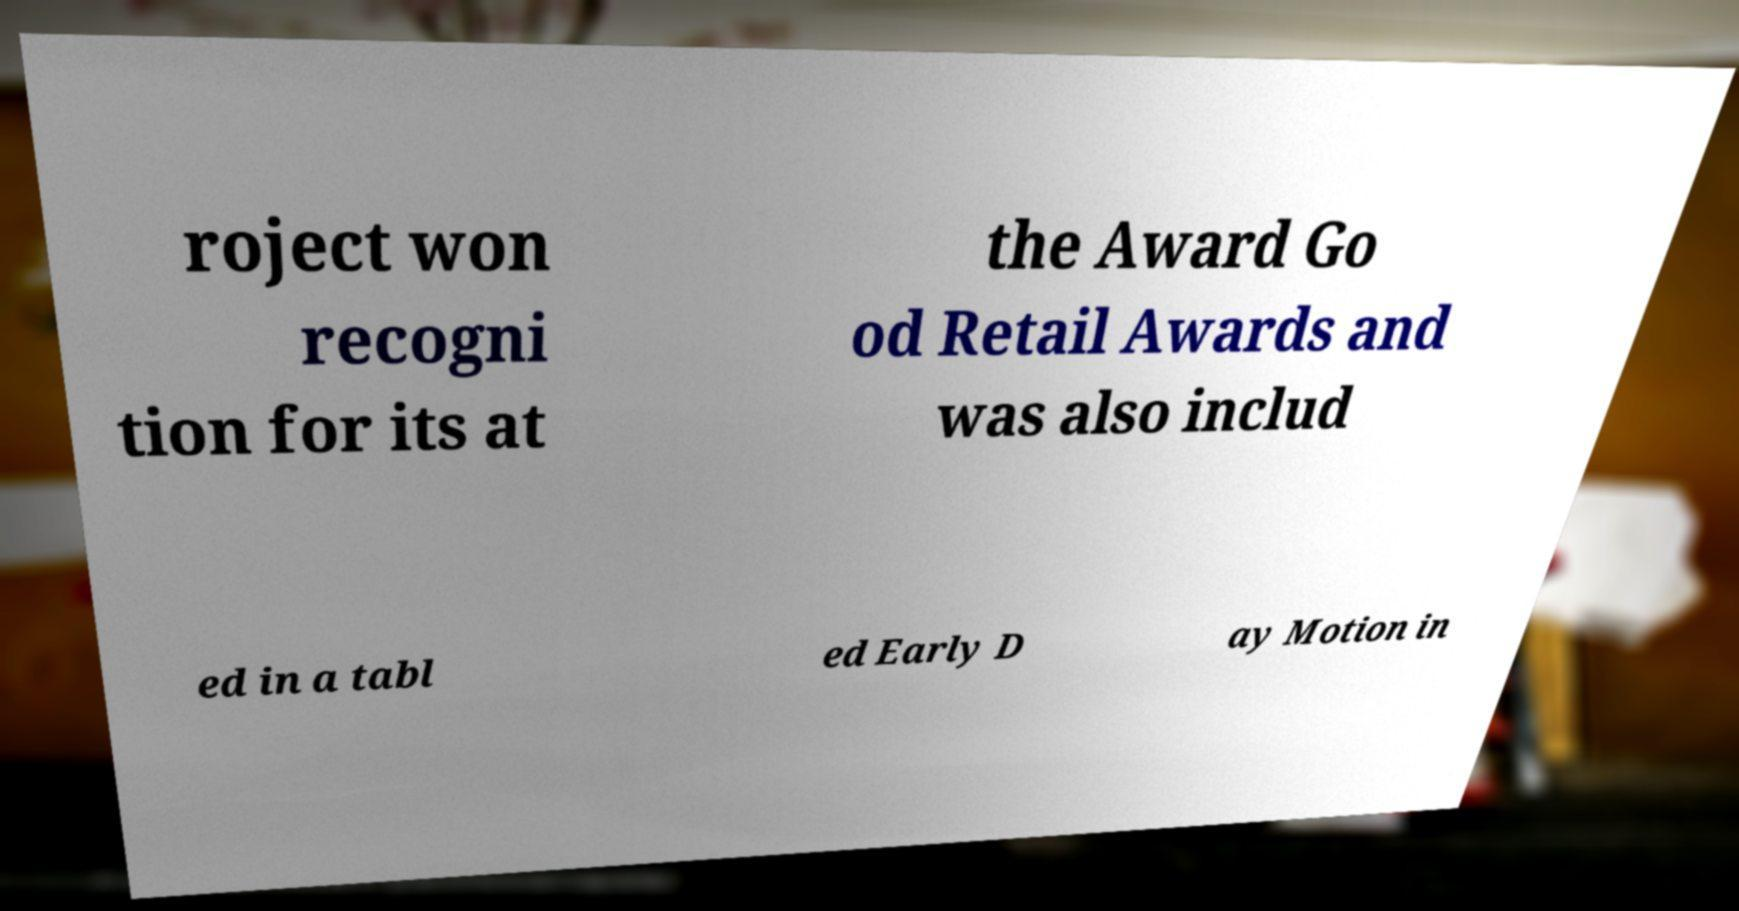There's text embedded in this image that I need extracted. Can you transcribe it verbatim? roject won recogni tion for its at the Award Go od Retail Awards and was also includ ed in a tabl ed Early D ay Motion in 